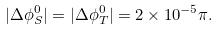Convert formula to latex. <formula><loc_0><loc_0><loc_500><loc_500>| \Delta \phi ^ { 0 } _ { S } | = | \Delta \phi ^ { 0 } _ { T } | = 2 \times 1 0 ^ { - 5 } \pi .</formula> 